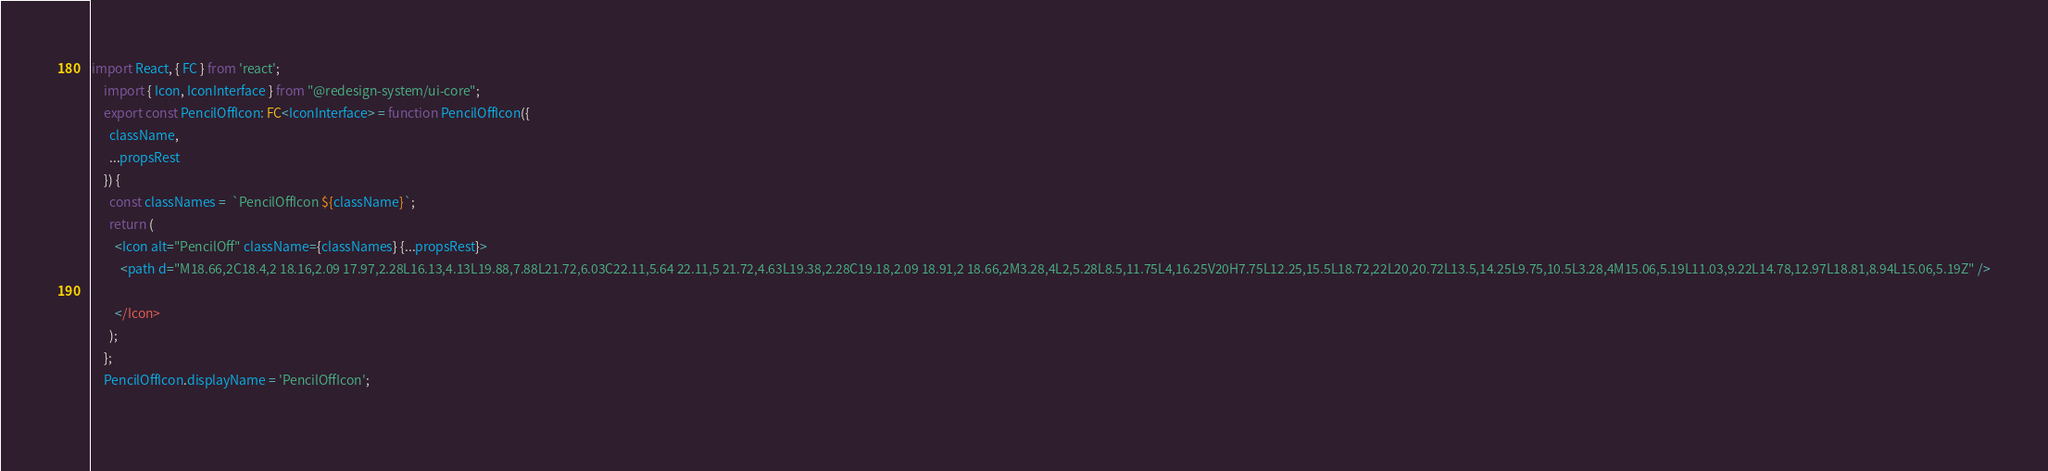Convert code to text. <code><loc_0><loc_0><loc_500><loc_500><_TypeScript_>import React, { FC } from 'react';
    import { Icon, IconInterface } from "@redesign-system/ui-core";
    export const PencilOffIcon: FC<IconInterface> = function PencilOffIcon({
      className,
      ...propsRest
    }) {
      const classNames =  `PencilOffIcon ${className}`;
      return (
        <Icon alt="PencilOff" className={classNames} {...propsRest}>
          <path d="M18.66,2C18.4,2 18.16,2.09 17.97,2.28L16.13,4.13L19.88,7.88L21.72,6.03C22.11,5.64 22.11,5 21.72,4.63L19.38,2.28C19.18,2.09 18.91,2 18.66,2M3.28,4L2,5.28L8.5,11.75L4,16.25V20H7.75L12.25,15.5L18.72,22L20,20.72L13.5,14.25L9.75,10.5L3.28,4M15.06,5.19L11.03,9.22L14.78,12.97L18.81,8.94L15.06,5.19Z" />

        </Icon>
      );
    };
    PencilOffIcon.displayName = 'PencilOffIcon';
      </code> 